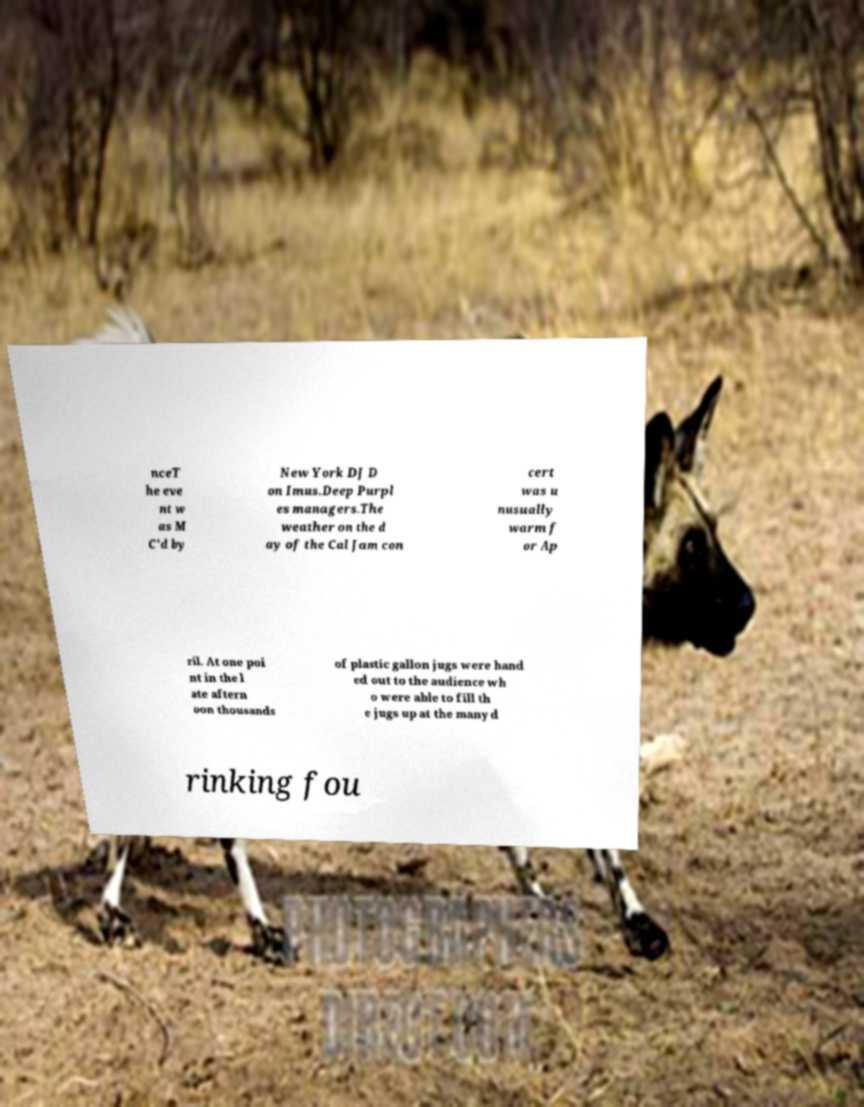Can you accurately transcribe the text from the provided image for me? nceT he eve nt w as M C'd by New York DJ D on Imus.Deep Purpl es managers.The weather on the d ay of the Cal Jam con cert was u nusually warm f or Ap ril. At one poi nt in the l ate aftern oon thousands of plastic gallon jugs were hand ed out to the audience wh o were able to fill th e jugs up at the many d rinking fou 